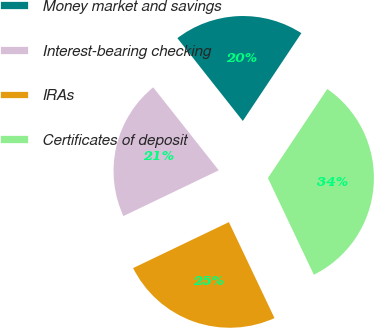<chart> <loc_0><loc_0><loc_500><loc_500><pie_chart><fcel>Money market and savings<fcel>Interest-bearing checking<fcel>IRAs<fcel>Certificates of deposit<nl><fcel>20.0%<fcel>21.48%<fcel>24.94%<fcel>33.58%<nl></chart> 